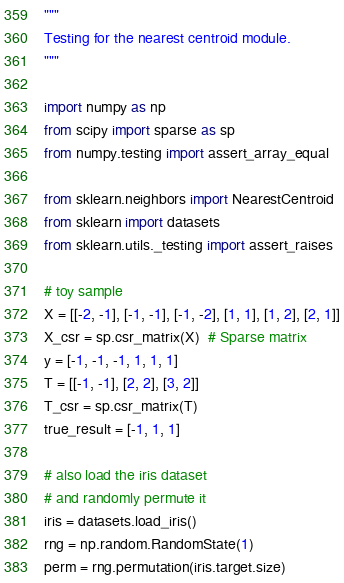<code> <loc_0><loc_0><loc_500><loc_500><_Python_>"""
Testing for the nearest centroid module.
"""

import numpy as np
from scipy import sparse as sp
from numpy.testing import assert_array_equal

from sklearn.neighbors import NearestCentroid
from sklearn import datasets
from sklearn.utils._testing import assert_raises

# toy sample
X = [[-2, -1], [-1, -1], [-1, -2], [1, 1], [1, 2], [2, 1]]
X_csr = sp.csr_matrix(X)  # Sparse matrix
y = [-1, -1, -1, 1, 1, 1]
T = [[-1, -1], [2, 2], [3, 2]]
T_csr = sp.csr_matrix(T)
true_result = [-1, 1, 1]

# also load the iris dataset
# and randomly permute it
iris = datasets.load_iris()
rng = np.random.RandomState(1)
perm = rng.permutation(iris.target.size)</code> 